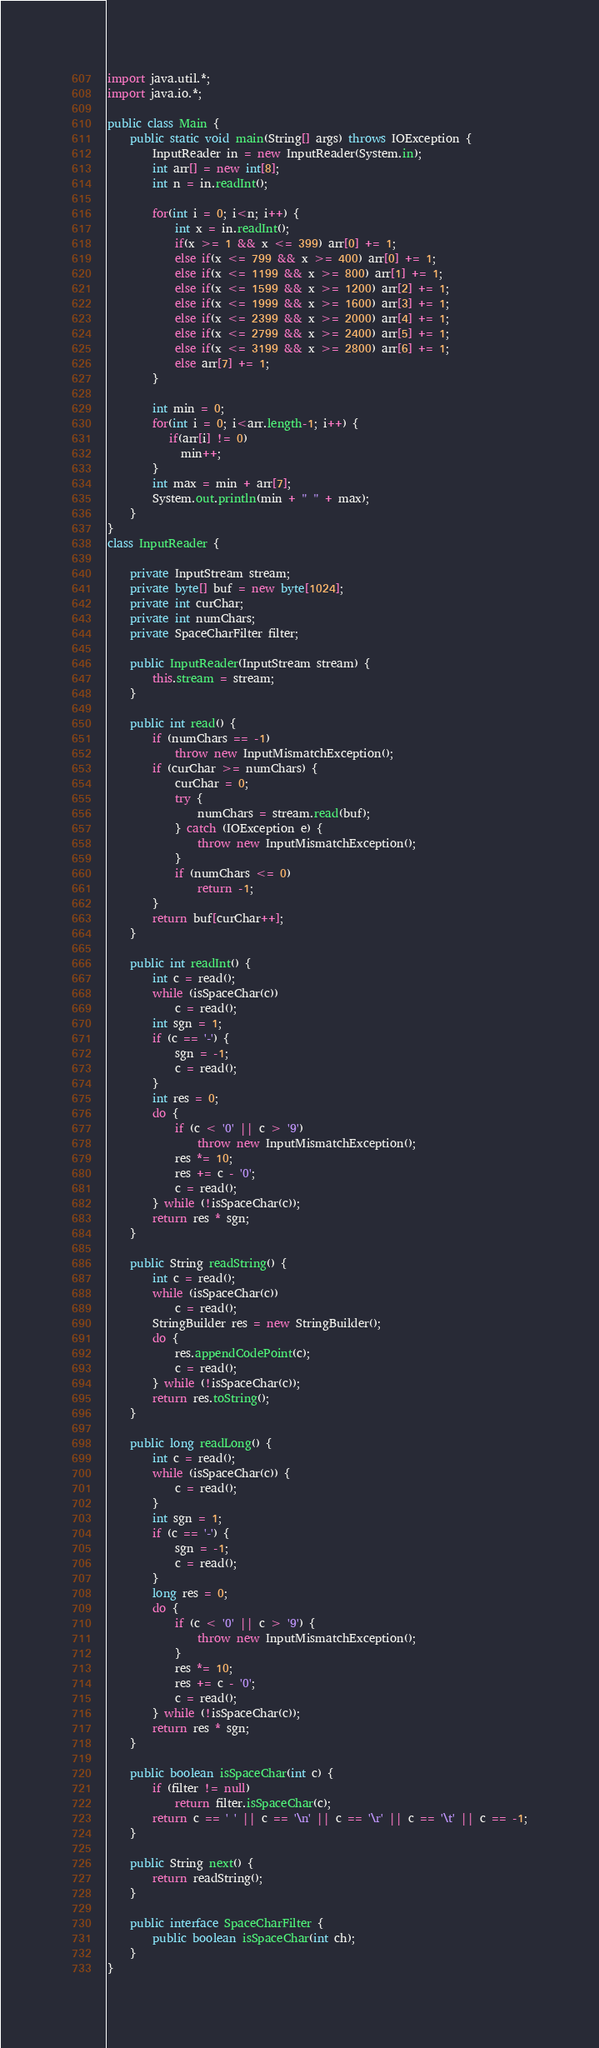<code> <loc_0><loc_0><loc_500><loc_500><_Java_>import java.util.*;
import java.io.*;

public class Main {
	public static void main(String[] args) throws IOException {
		InputReader in = new InputReader(System.in);
		int arr[] = new int[8]; 
		int n = in.readInt(); 
		
		for(int i = 0; i<n; i++) {
			int x = in.readInt(); 
			if(x >= 1 && x <= 399) arr[0] += 1;
			else if(x <= 799 && x >= 400) arr[0] += 1;
			else if(x <= 1199 && x >= 800) arr[1] += 1;
			else if(x <= 1599 && x >= 1200) arr[2] += 1;
			else if(x <= 1999 && x >= 1600) arr[3] += 1;
			else if(x <= 2399 && x >= 2000) arr[4] += 1;
			else if(x <= 2799 && x >= 2400) arr[5] += 1;
			else if(x <= 3199 && x >= 2800) arr[6] += 1;
			else arr[7] += 1; 
		}
		
		int min = 0; 
		for(int i = 0; i<arr.length-1; i++) {
		   if(arr[i] != 0)
			 min++; 
		}
		int max = min + arr[7]; 
		System.out.println(min + " " + max); 
	}
}
class InputReader {

	private InputStream stream;
	private byte[] buf = new byte[1024];
	private int curChar;
	private int numChars;
	private SpaceCharFilter filter;

	public InputReader(InputStream stream) {
		this.stream = stream;
	}

	public int read() {
		if (numChars == -1)
			throw new InputMismatchException();
		if (curChar >= numChars) {
			curChar = 0;
			try {
				numChars = stream.read(buf);
			} catch (IOException e) {
				throw new InputMismatchException();
			}
			if (numChars <= 0)
				return -1;
		}
		return buf[curChar++];
	}

	public int readInt() {
		int c = read();
		while (isSpaceChar(c))
			c = read();
		int sgn = 1;
		if (c == '-') {
			sgn = -1;
			c = read();
		}
		int res = 0;
		do {
			if (c < '0' || c > '9')
				throw new InputMismatchException();
			res *= 10;
			res += c - '0';
			c = read();
		} while (!isSpaceChar(c));
		return res * sgn;
	}

	public String readString() {
		int c = read();
		while (isSpaceChar(c))
			c = read();
		StringBuilder res = new StringBuilder();
		do {
			res.appendCodePoint(c);
			c = read();
		} while (!isSpaceChar(c));
		return res.toString();
	}

	public long readLong() {
		int c = read();
		while (isSpaceChar(c)) {
			c = read();
		}
		int sgn = 1;
		if (c == '-') {
			sgn = -1;
			c = read();
		}
		long res = 0;
		do {
			if (c < '0' || c > '9') {
				throw new InputMismatchException();
			}
			res *= 10;
			res += c - '0';
			c = read();
		} while (!isSpaceChar(c));
		return res * sgn;
	}
	
	public boolean isSpaceChar(int c) {
		if (filter != null)
			return filter.isSpaceChar(c);
		return c == ' ' || c == '\n' || c == '\r' || c == '\t' || c == -1;
	}

	public String next() {
		return readString();
	}

	public interface SpaceCharFilter {
		public boolean isSpaceChar(int ch);
	}
}
</code> 